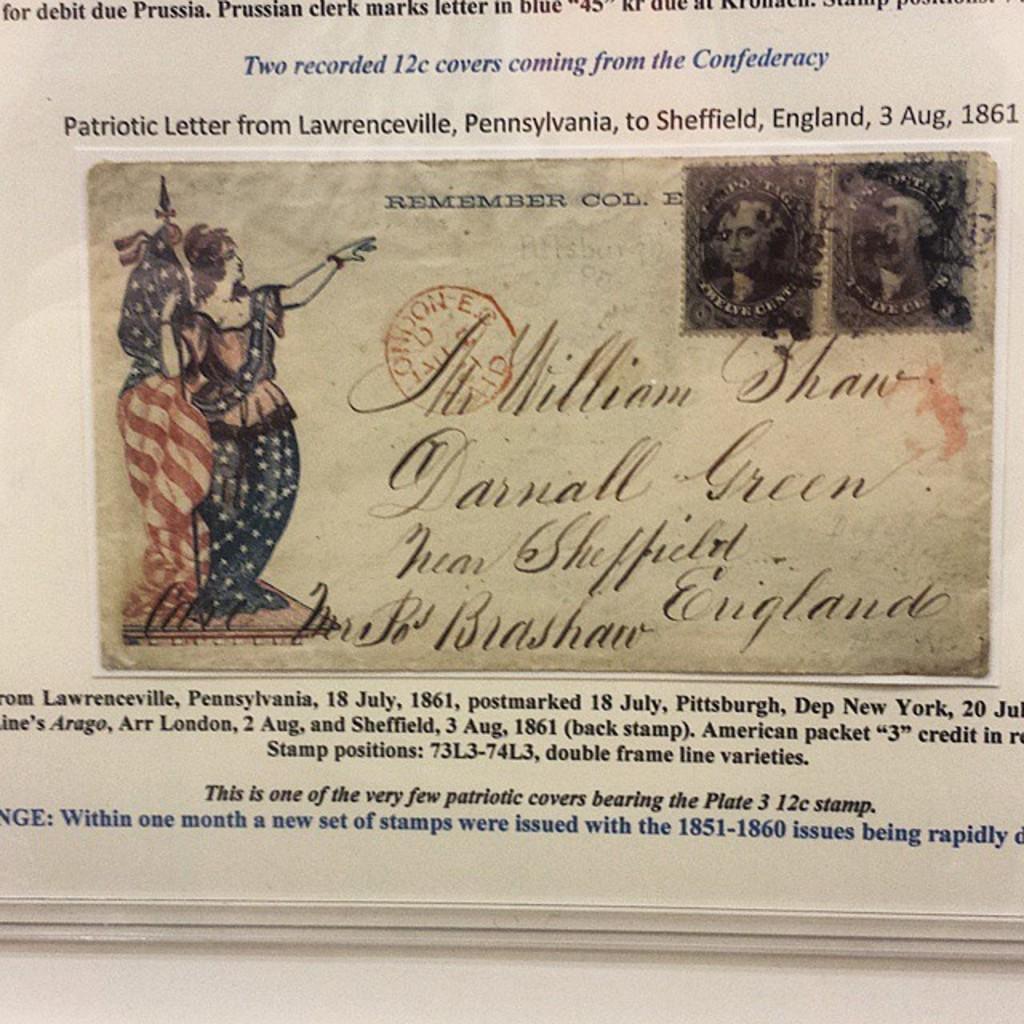Please provide a concise description of this image. It is a poster. In this image there are depictions of persons and there is some text. 